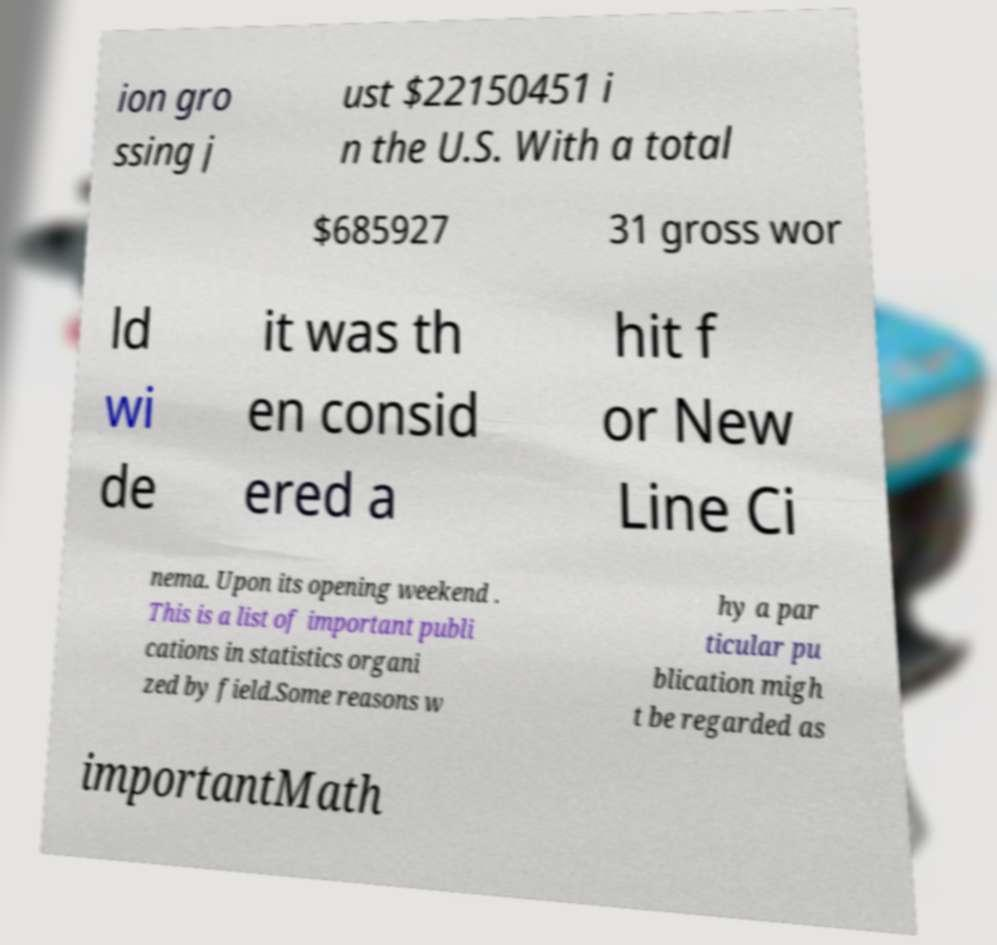What messages or text are displayed in this image? I need them in a readable, typed format. ion gro ssing j ust $22150451 i n the U.S. With a total $685927 31 gross wor ld wi de it was th en consid ered a hit f or New Line Ci nema. Upon its opening weekend . This is a list of important publi cations in statistics organi zed by field.Some reasons w hy a par ticular pu blication migh t be regarded as importantMath 